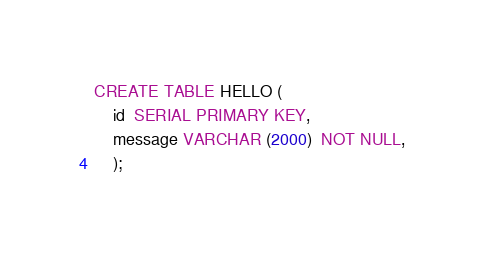<code> <loc_0><loc_0><loc_500><loc_500><_SQL_>CREATE TABLE HELLO (
    id  SERIAL PRIMARY KEY,
    message VARCHAR (2000)  NOT NULL,
    );</code> 